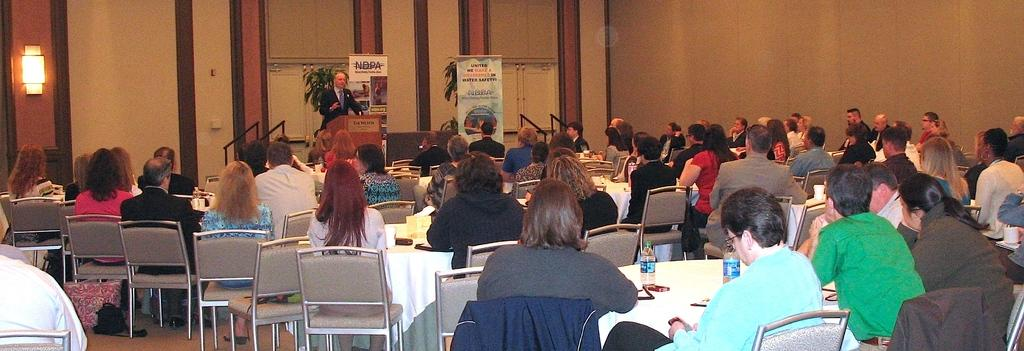What are the people in the image doing? The people in the image are sitting on chairs. Can you describe the man in the image? There is a man standing in the image. What is the name of the man's son in the image? There is no mention of a son or any names in the image. 